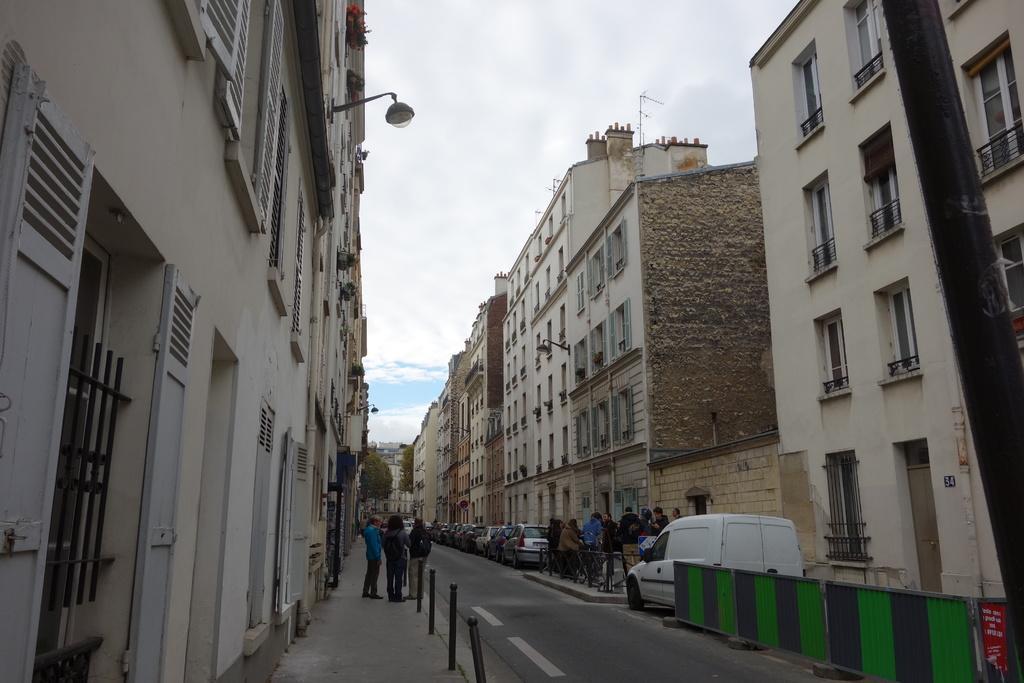Please provide a concise description of this image. These are the buildings with the windows and doors. I can see groups of people standing. I think these are the lane poles. I can see the vehicles, which are parked on the road. These look like the barricades. This is a pole. Here is the sky. I can see a lamp, which is attached to a building wall. In the background, I can see the trees. 